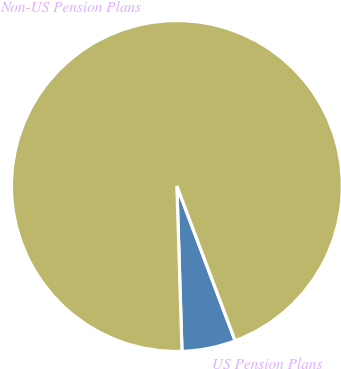<chart> <loc_0><loc_0><loc_500><loc_500><pie_chart><fcel>US Pension Plans<fcel>Non-US Pension Plans<nl><fcel>5.24%<fcel>94.76%<nl></chart> 